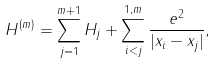Convert formula to latex. <formula><loc_0><loc_0><loc_500><loc_500>H ^ { ( m ) } = \sum _ { j = 1 } ^ { m + 1 } H _ { j } + \sum _ { i < j } ^ { 1 , m } \frac { e ^ { 2 } } { | x _ { i } - x _ { j } | } ,</formula> 